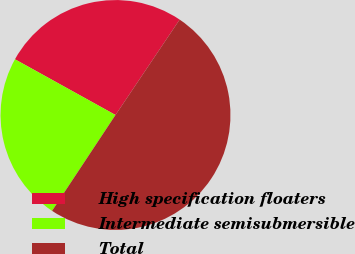Convert chart. <chart><loc_0><loc_0><loc_500><loc_500><pie_chart><fcel>High specification floaters<fcel>Intermediate semisubmersible<fcel>Total<nl><fcel>26.37%<fcel>23.75%<fcel>49.88%<nl></chart> 